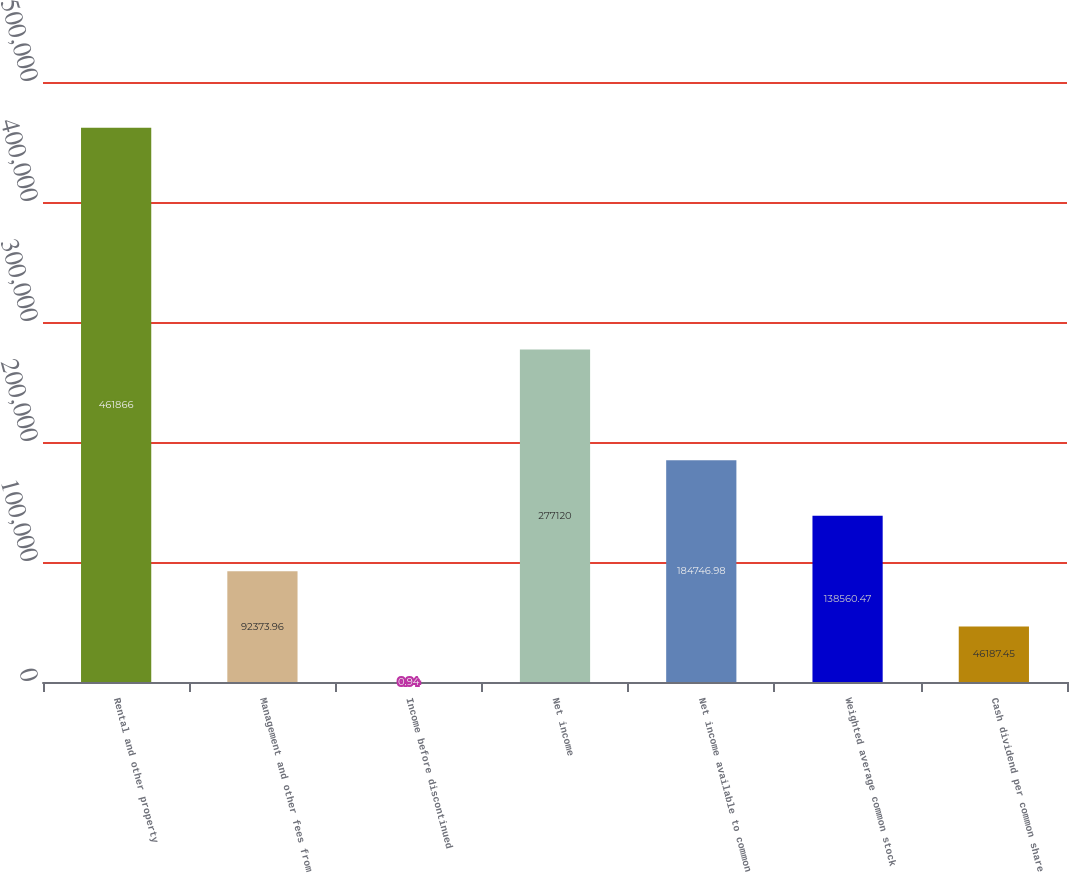<chart> <loc_0><loc_0><loc_500><loc_500><bar_chart><fcel>Rental and other property<fcel>Management and other fees from<fcel>Income before discontinued<fcel>Net income<fcel>Net income available to common<fcel>Weighted average common stock<fcel>Cash dividend per common share<nl><fcel>461866<fcel>92374<fcel>0.94<fcel>277120<fcel>184747<fcel>138560<fcel>46187.4<nl></chart> 